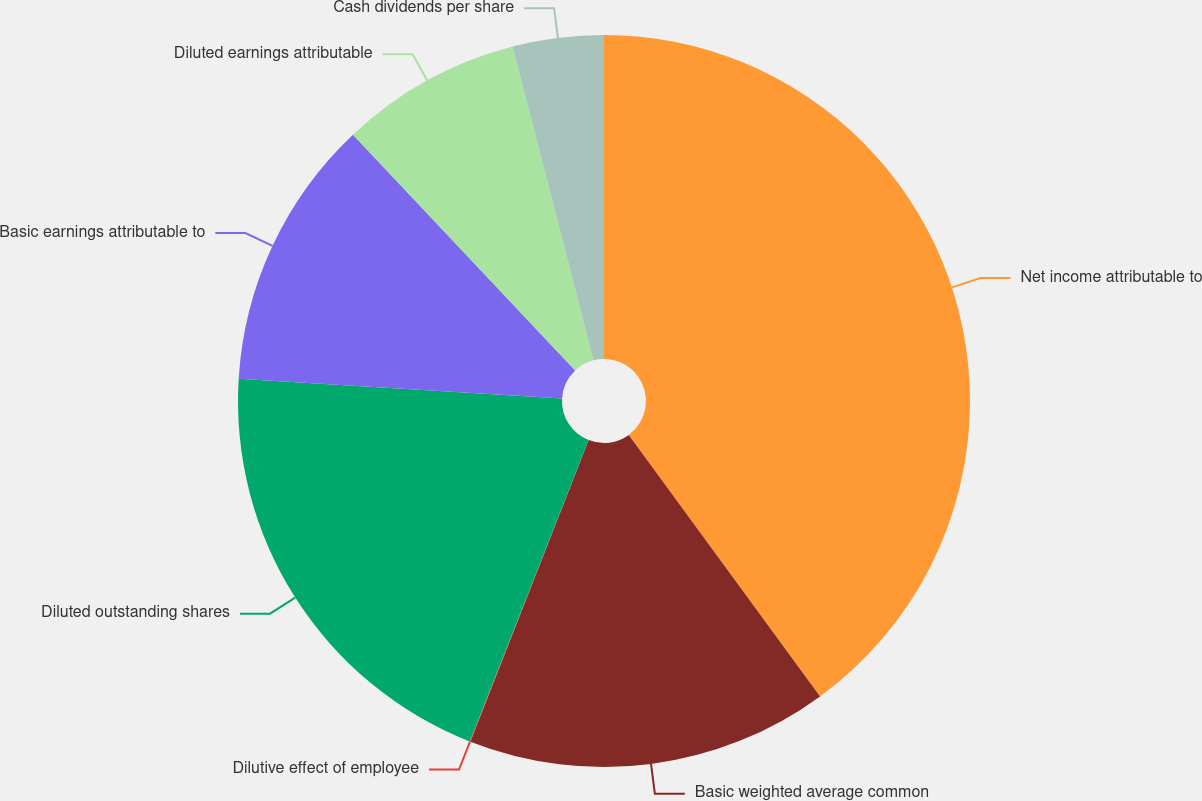Convert chart. <chart><loc_0><loc_0><loc_500><loc_500><pie_chart><fcel>Net income attributable to<fcel>Basicweighted average common<fcel>Dilutive effect of employee<fcel>Diluted outstanding shares<fcel>Basic earnings attributable to<fcel>Diluted earnings attributable<fcel>Cash dividends per share<nl><fcel>39.95%<fcel>16.0%<fcel>0.03%<fcel>19.99%<fcel>12.0%<fcel>8.01%<fcel>4.02%<nl></chart> 